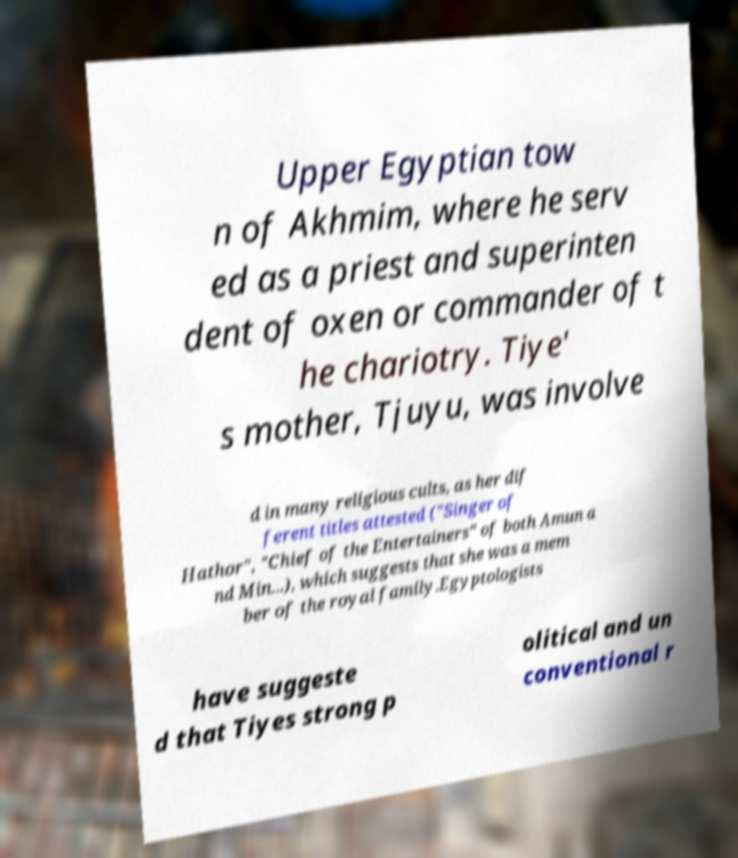Can you read and provide the text displayed in the image?This photo seems to have some interesting text. Can you extract and type it out for me? Upper Egyptian tow n of Akhmim, where he serv ed as a priest and superinten dent of oxen or commander of t he chariotry. Tiye' s mother, Tjuyu, was involve d in many religious cults, as her dif ferent titles attested ("Singer of Hathor", "Chief of the Entertainers" of both Amun a nd Min...), which suggests that she was a mem ber of the royal family.Egyptologists have suggeste d that Tiyes strong p olitical and un conventional r 